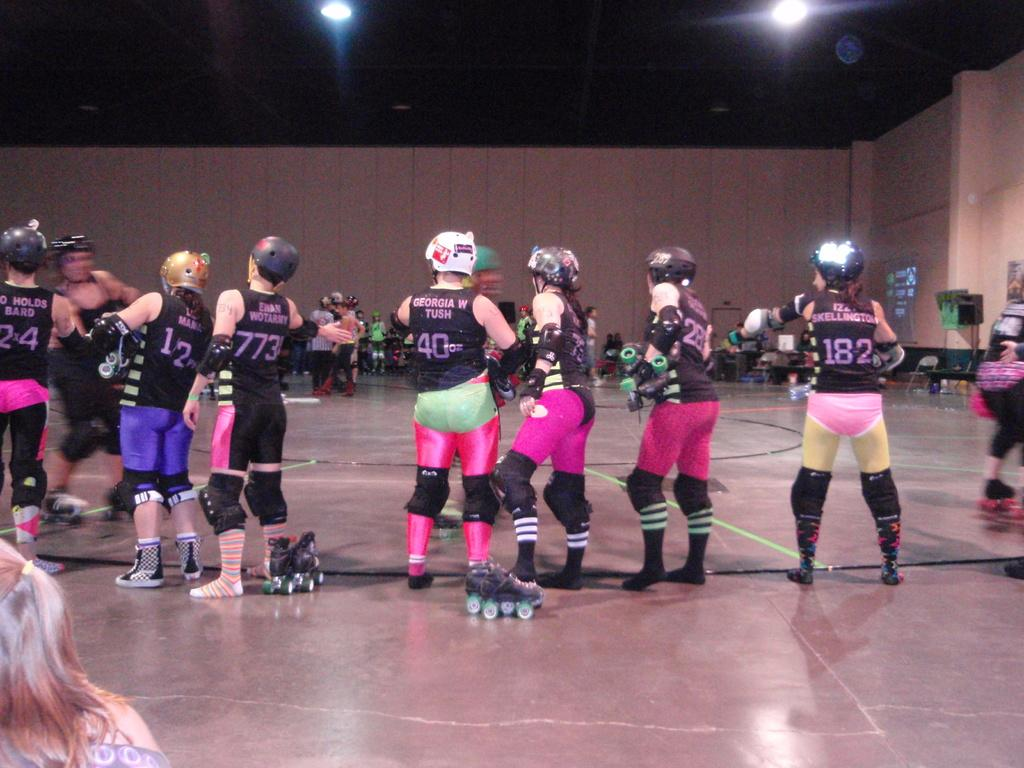Who or what is present in the image? There are people in the image. What can be seen beneath the people's feet? The floor is visible in the image. What is located behind the people? There is a wall in the background of the image. What can be heard in the image? There are speakers in the background of the image, which might be used for playing music or other sounds. What can be seen illuminating the background? There are lights in the background of the image. What else can be seen in the background of the image? There are objects in the background of the image. How many books are stacked on the snake in the image? There is no snake or books present in the image. 